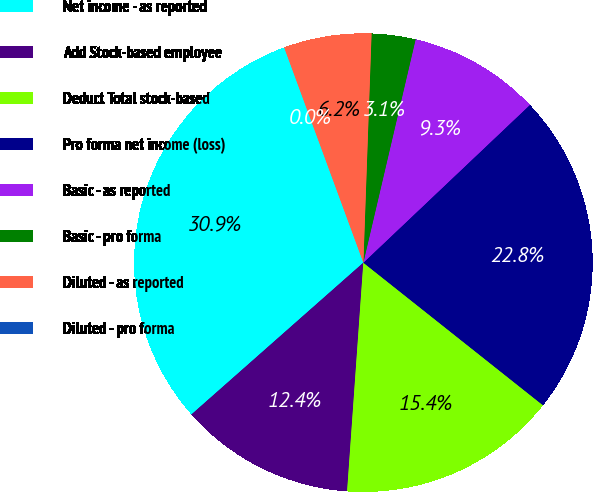Convert chart. <chart><loc_0><loc_0><loc_500><loc_500><pie_chart><fcel>Net income - as reported<fcel>Add Stock-based employee<fcel>Deduct Total stock-based<fcel>Pro forma net income (loss)<fcel>Basic - as reported<fcel>Basic - pro forma<fcel>Diluted - as reported<fcel>Diluted - pro forma<nl><fcel>30.9%<fcel>12.36%<fcel>15.45%<fcel>22.75%<fcel>9.27%<fcel>3.09%<fcel>6.18%<fcel>0.0%<nl></chart> 